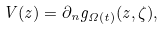<formula> <loc_0><loc_0><loc_500><loc_500>V ( z ) = \partial _ { n } g _ { \Omega ( t ) } ( z , \zeta ) ,</formula> 